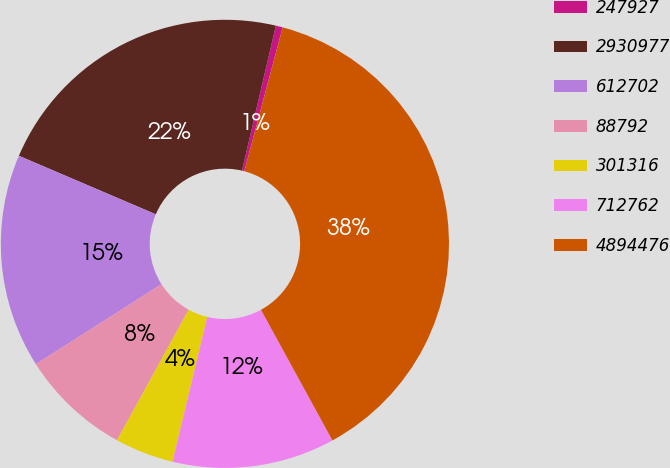Convert chart. <chart><loc_0><loc_0><loc_500><loc_500><pie_chart><fcel>247927<fcel>2930977<fcel>612702<fcel>88792<fcel>301316<fcel>712762<fcel>4894476<nl><fcel>0.5%<fcel>22.22%<fcel>15.45%<fcel>7.98%<fcel>4.24%<fcel>11.72%<fcel>37.88%<nl></chart> 